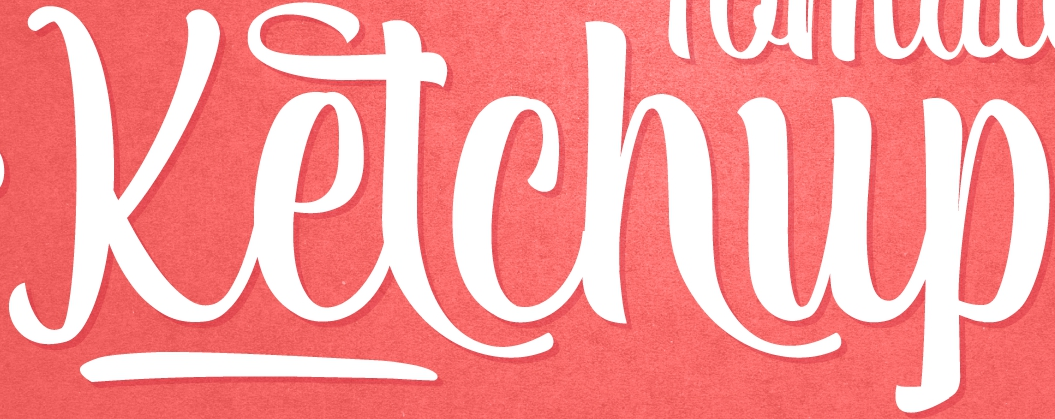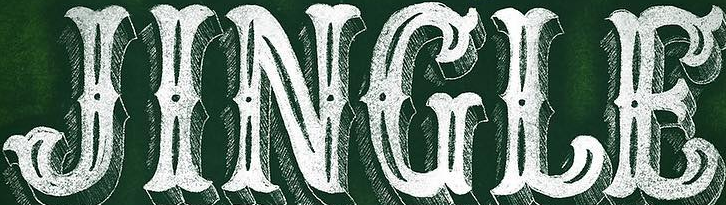Read the text content from these images in order, separated by a semicolon. Ketchup; JINGLE 